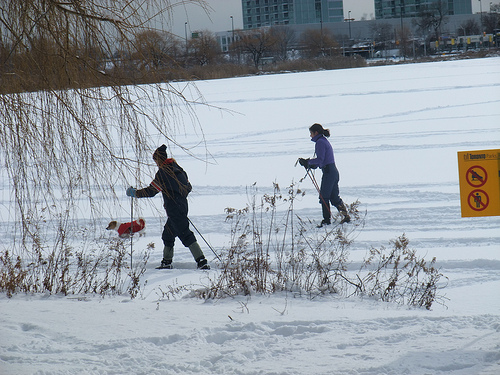Describe the environment and weather in the image. The image depicts a wintry setting, characterized by a blanket of snow covering the ground. The sky is overcast, suggesting a chilly atmosphere. There are bare trees and dry shrubbery partially covered in snow, indicating that the photograph was taken during the colder months. A frozen body of water can be seen in the background, and the overall scene exudes a serene, yet cold ambiance. 